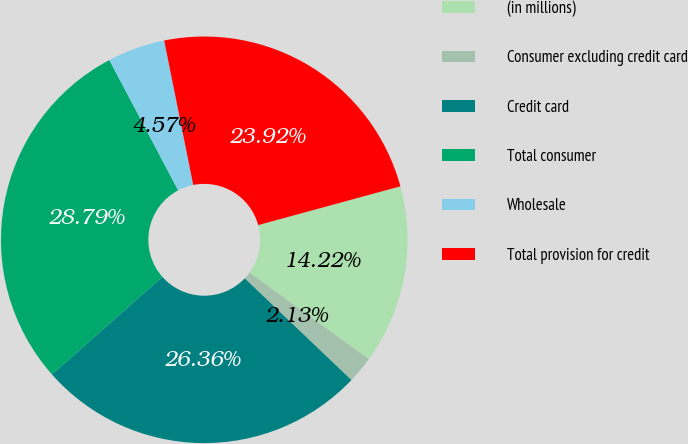Convert chart. <chart><loc_0><loc_0><loc_500><loc_500><pie_chart><fcel>(in millions)<fcel>Consumer excluding credit card<fcel>Credit card<fcel>Total consumer<fcel>Wholesale<fcel>Total provision for credit<nl><fcel>14.22%<fcel>2.13%<fcel>26.36%<fcel>28.79%<fcel>4.57%<fcel>23.92%<nl></chart> 